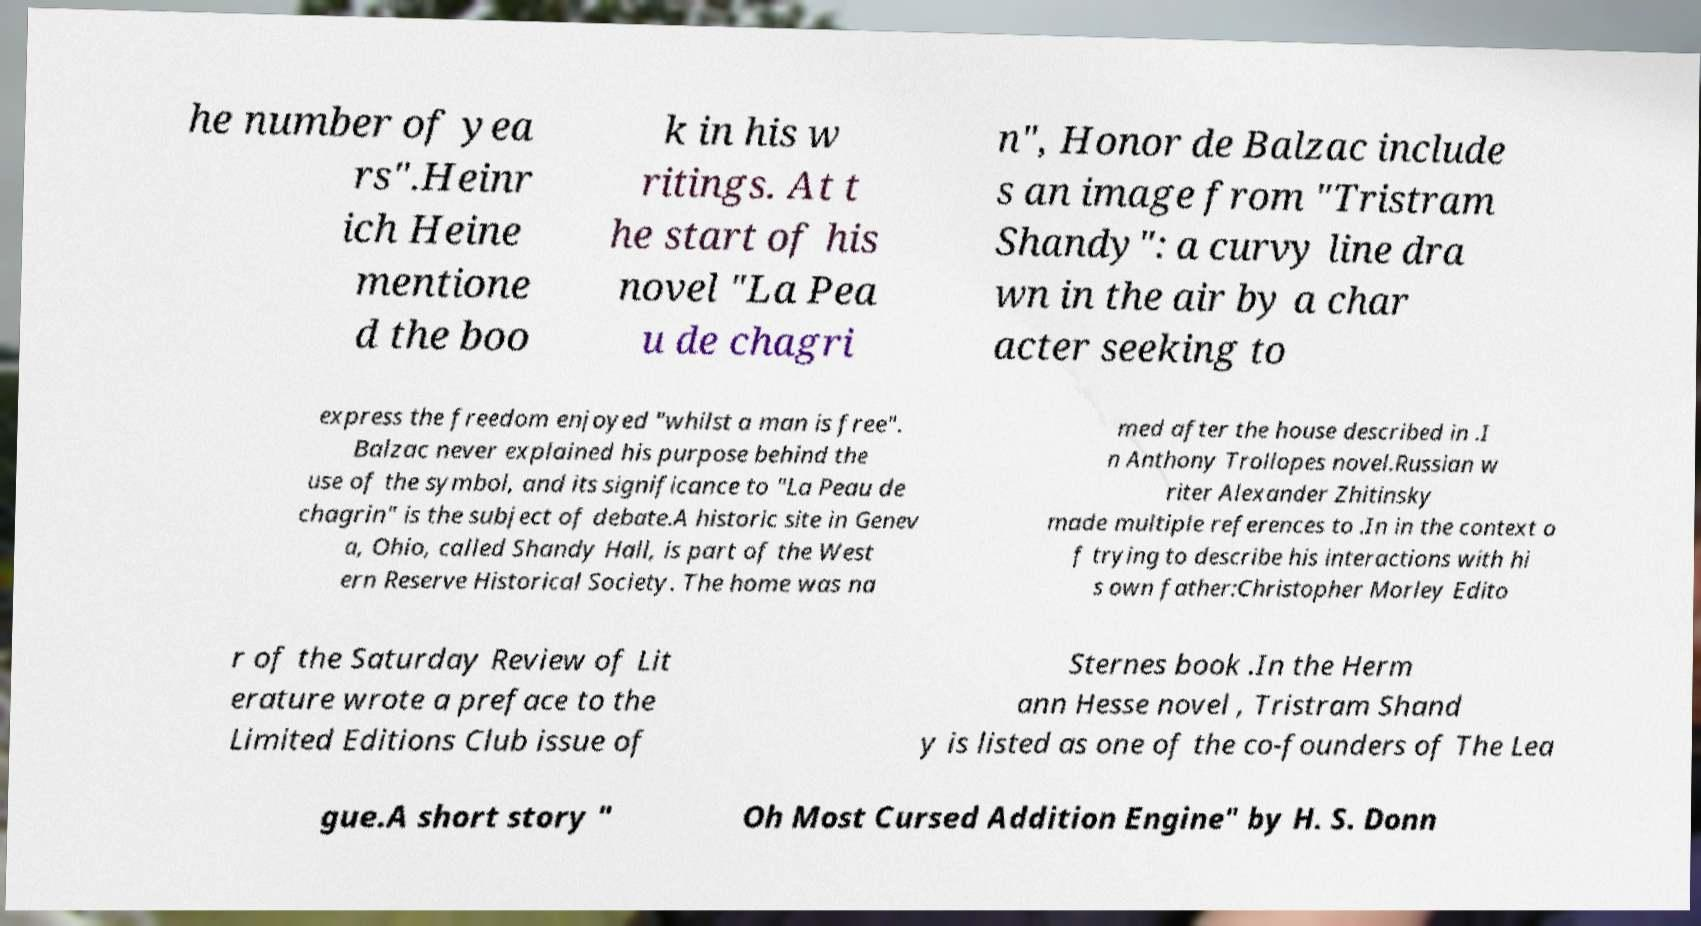Could you extract and type out the text from this image? he number of yea rs".Heinr ich Heine mentione d the boo k in his w ritings. At t he start of his novel "La Pea u de chagri n", Honor de Balzac include s an image from "Tristram Shandy": a curvy line dra wn in the air by a char acter seeking to express the freedom enjoyed "whilst a man is free". Balzac never explained his purpose behind the use of the symbol, and its significance to "La Peau de chagrin" is the subject of debate.A historic site in Genev a, Ohio, called Shandy Hall, is part of the West ern Reserve Historical Society. The home was na med after the house described in .I n Anthony Trollopes novel.Russian w riter Alexander Zhitinsky made multiple references to .In in the context o f trying to describe his interactions with hi s own father:Christopher Morley Edito r of the Saturday Review of Lit erature wrote a preface to the Limited Editions Club issue of Sternes book .In the Herm ann Hesse novel , Tristram Shand y is listed as one of the co-founders of The Lea gue.A short story " Oh Most Cursed Addition Engine" by H. S. Donn 